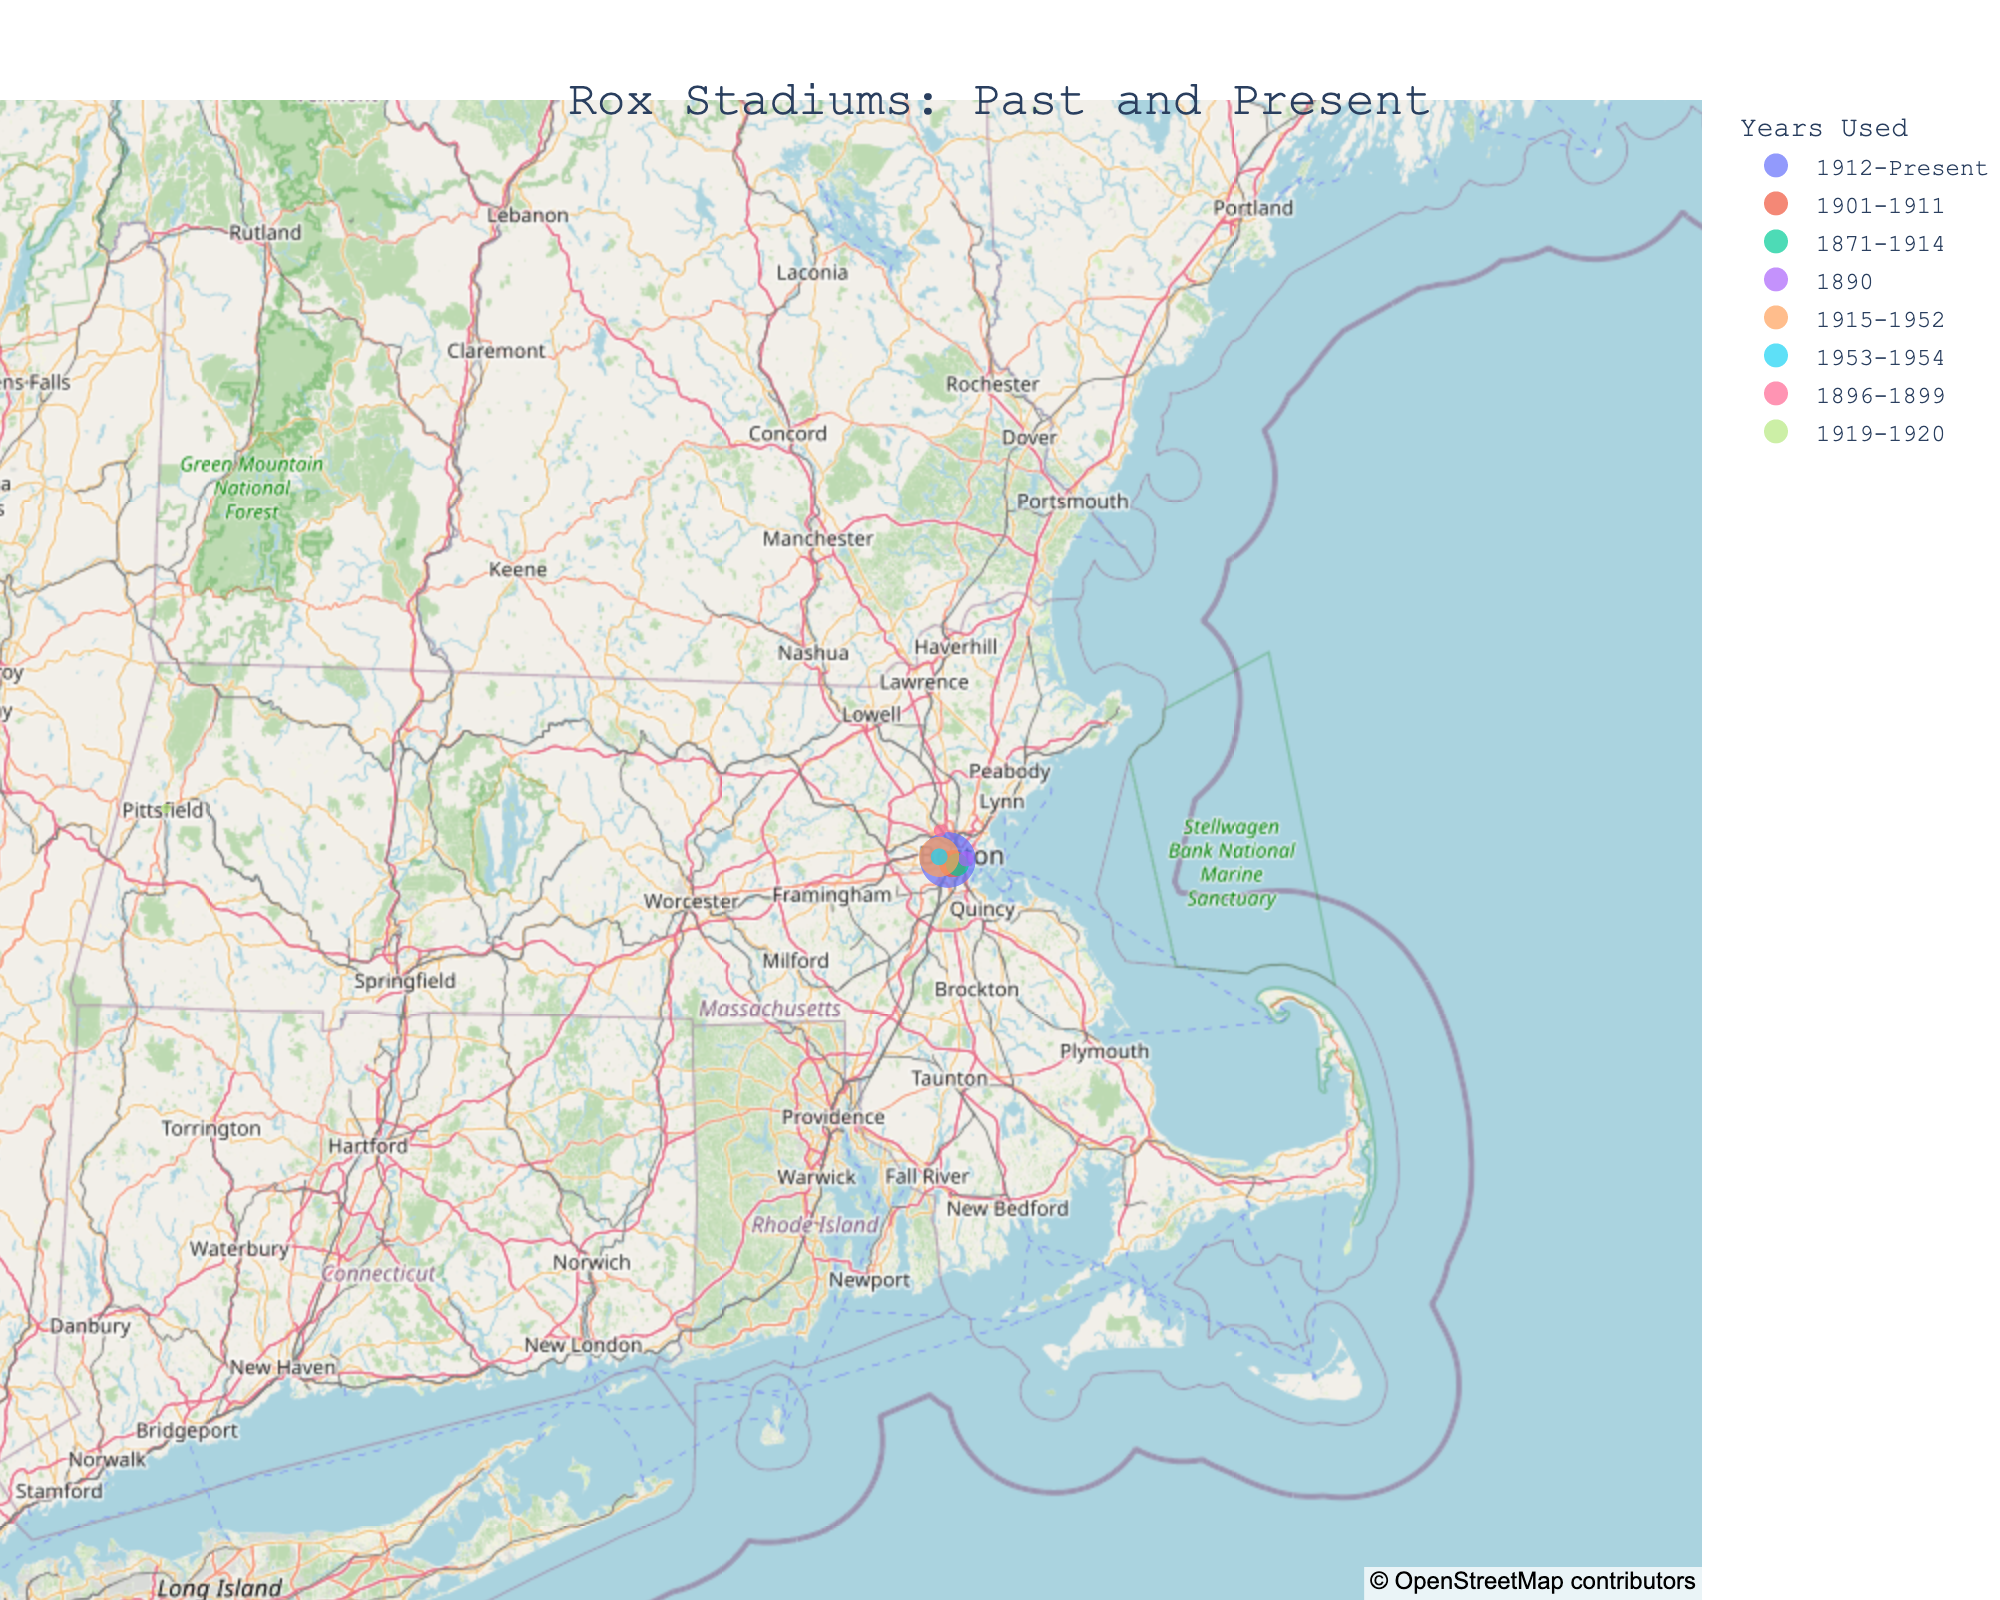What is the title of the figure? The title is usually prominently displayed at the top of the figure in larger fonts than the other text. The title of the figure in this case would convey the main theme or subject of the plot.
Answer: Rox Stadiums: Past and Present Which stadium has the highest average attendance? By looking at the size of the circles in the geographic plot, the largest circle indicates the stadium with the highest average attendance.
Answer: Fenway Park How many stadiums are shown on the map? You can count the number of data points (circles) that appear on the map to determine the total number of stadiums displayed.
Answer: 8 Which stadium was used for the shortest period, and what was its average attendance? The stadium used for the shortest period can be found by looking at the "Years Used" legend and finding the smallest duration. In this case, locate the stadium with just one year listed.
Answer: Congress Street Grounds, 2912 What is the geographical range covered by the Rox stadiums? Analyze the figure to determine the northernmost, southernmost, easternmost, and westernmost points based on the latitude and longitude values marking the stadium locations.
Answer: Northmost: Pittsfield Elm Street Grounds, Southmost: South End Grounds, Eastmost: Congress Street Grounds, Westmost: Pittsfield Elm Street Grounds Which stadium is located furthest west? Identifying the stadium by examining the longitude values in the map; the one with the highest negative longitude value (furthest left on the map) is the westernmost stadium.
Answer: Pittsfield Elm Street Grounds Which stadium appears twice on the map under different names or purposes? By observing the plot, the location shared by two stadiums based on the exact latitude and longitude points would indicate the same venue used differently over time.
Answer: Braves Field and Nickerson Field Are there any stadiums located outside Boston? Assessing the stadiums list, find any data points not within the city of Boston by their city entries. On the map, one would see points scattered around Boston.
Answer: Yes, Tufts Oval and Pittsfield Elm Street Grounds Which stadium was used most recently other than Fenway Park? Check the "Years Used" legend to find the most recent year range, excluding Fenway Park.
Answer: Nickerson Field 